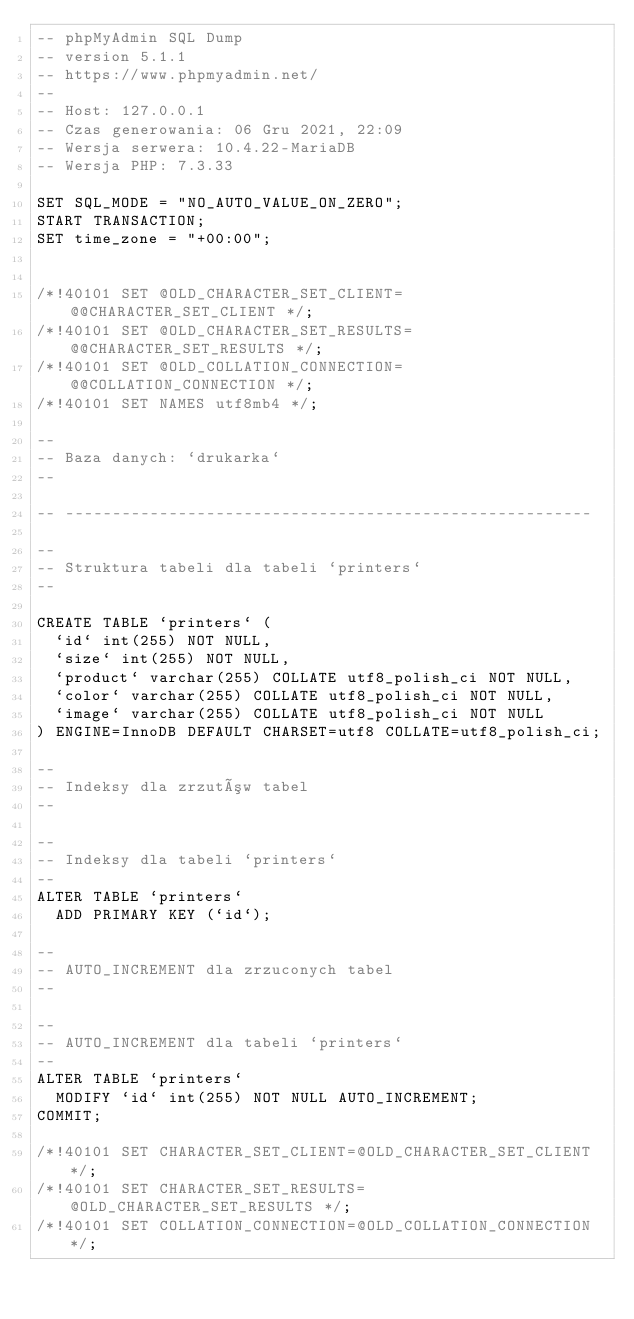<code> <loc_0><loc_0><loc_500><loc_500><_SQL_>-- phpMyAdmin SQL Dump
-- version 5.1.1
-- https://www.phpmyadmin.net/
--
-- Host: 127.0.0.1
-- Czas generowania: 06 Gru 2021, 22:09
-- Wersja serwera: 10.4.22-MariaDB
-- Wersja PHP: 7.3.33

SET SQL_MODE = "NO_AUTO_VALUE_ON_ZERO";
START TRANSACTION;
SET time_zone = "+00:00";


/*!40101 SET @OLD_CHARACTER_SET_CLIENT=@@CHARACTER_SET_CLIENT */;
/*!40101 SET @OLD_CHARACTER_SET_RESULTS=@@CHARACTER_SET_RESULTS */;
/*!40101 SET @OLD_COLLATION_CONNECTION=@@COLLATION_CONNECTION */;
/*!40101 SET NAMES utf8mb4 */;

--
-- Baza danych: `drukarka`
--

-- --------------------------------------------------------

--
-- Struktura tabeli dla tabeli `printers`
--

CREATE TABLE `printers` (
  `id` int(255) NOT NULL,
  `size` int(255) NOT NULL,
  `product` varchar(255) COLLATE utf8_polish_ci NOT NULL,
  `color` varchar(255) COLLATE utf8_polish_ci NOT NULL,
  `image` varchar(255) COLLATE utf8_polish_ci NOT NULL
) ENGINE=InnoDB DEFAULT CHARSET=utf8 COLLATE=utf8_polish_ci;

--
-- Indeksy dla zrzutów tabel
--

--
-- Indeksy dla tabeli `printers`
--
ALTER TABLE `printers`
  ADD PRIMARY KEY (`id`);

--
-- AUTO_INCREMENT dla zrzuconych tabel
--

--
-- AUTO_INCREMENT dla tabeli `printers`
--
ALTER TABLE `printers`
  MODIFY `id` int(255) NOT NULL AUTO_INCREMENT;
COMMIT;

/*!40101 SET CHARACTER_SET_CLIENT=@OLD_CHARACTER_SET_CLIENT */;
/*!40101 SET CHARACTER_SET_RESULTS=@OLD_CHARACTER_SET_RESULTS */;
/*!40101 SET COLLATION_CONNECTION=@OLD_COLLATION_CONNECTION */;
</code> 